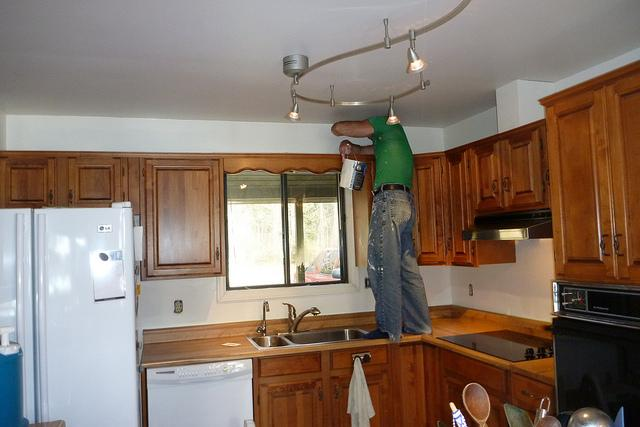Why is the man on the counter? Please explain your reasoning. to paint. He has a paint bucket in his hand. 